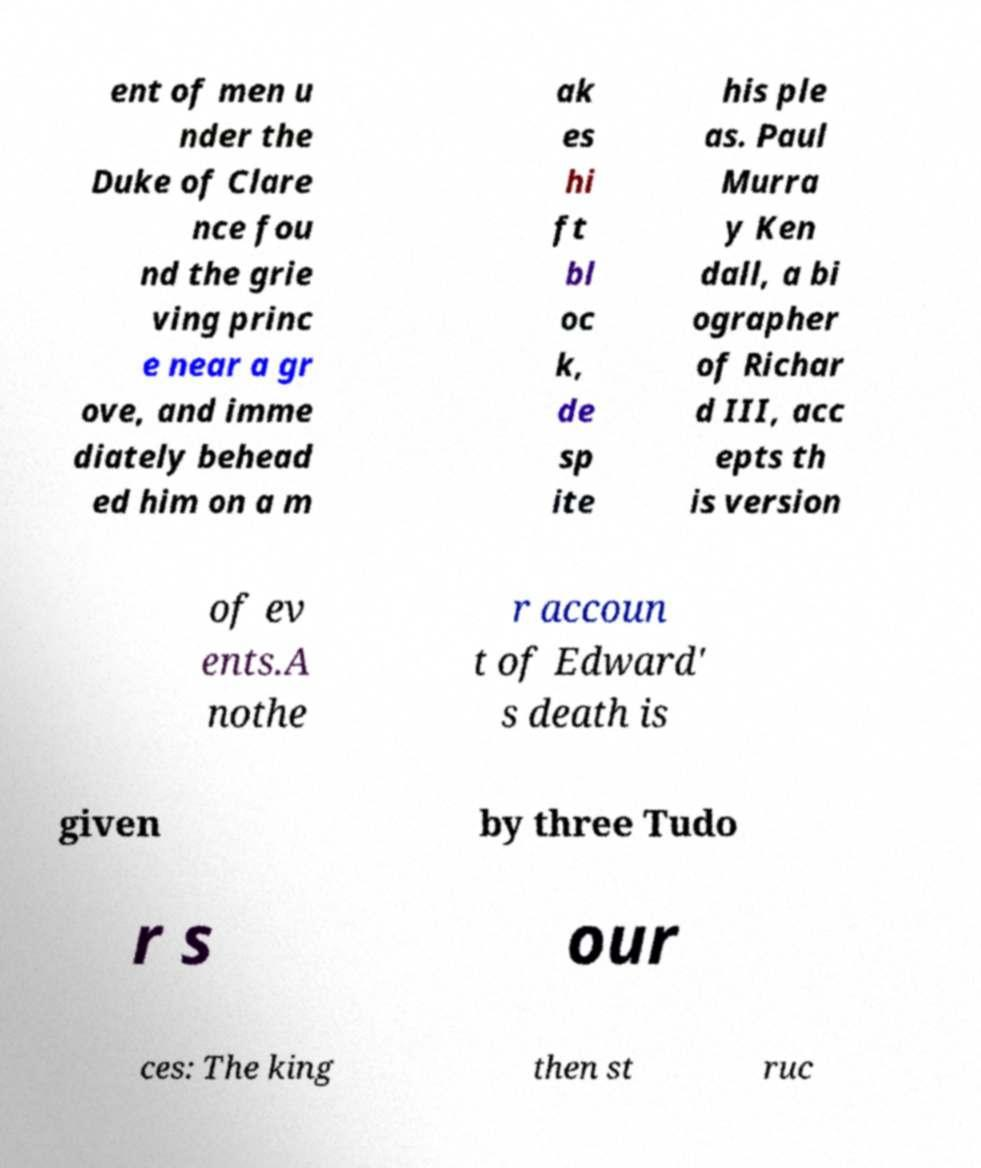Can you read and provide the text displayed in the image?This photo seems to have some interesting text. Can you extract and type it out for me? ent of men u nder the Duke of Clare nce fou nd the grie ving princ e near a gr ove, and imme diately behead ed him on a m ak es hi ft bl oc k, de sp ite his ple as. Paul Murra y Ken dall, a bi ographer of Richar d III, acc epts th is version of ev ents.A nothe r accoun t of Edward' s death is given by three Tudo r s our ces: The king then st ruc 